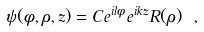Convert formula to latex. <formula><loc_0><loc_0><loc_500><loc_500>\psi ( \phi , \rho , z ) = C e ^ { i l \phi } e ^ { i k z } R ( \rho ) \ ,</formula> 